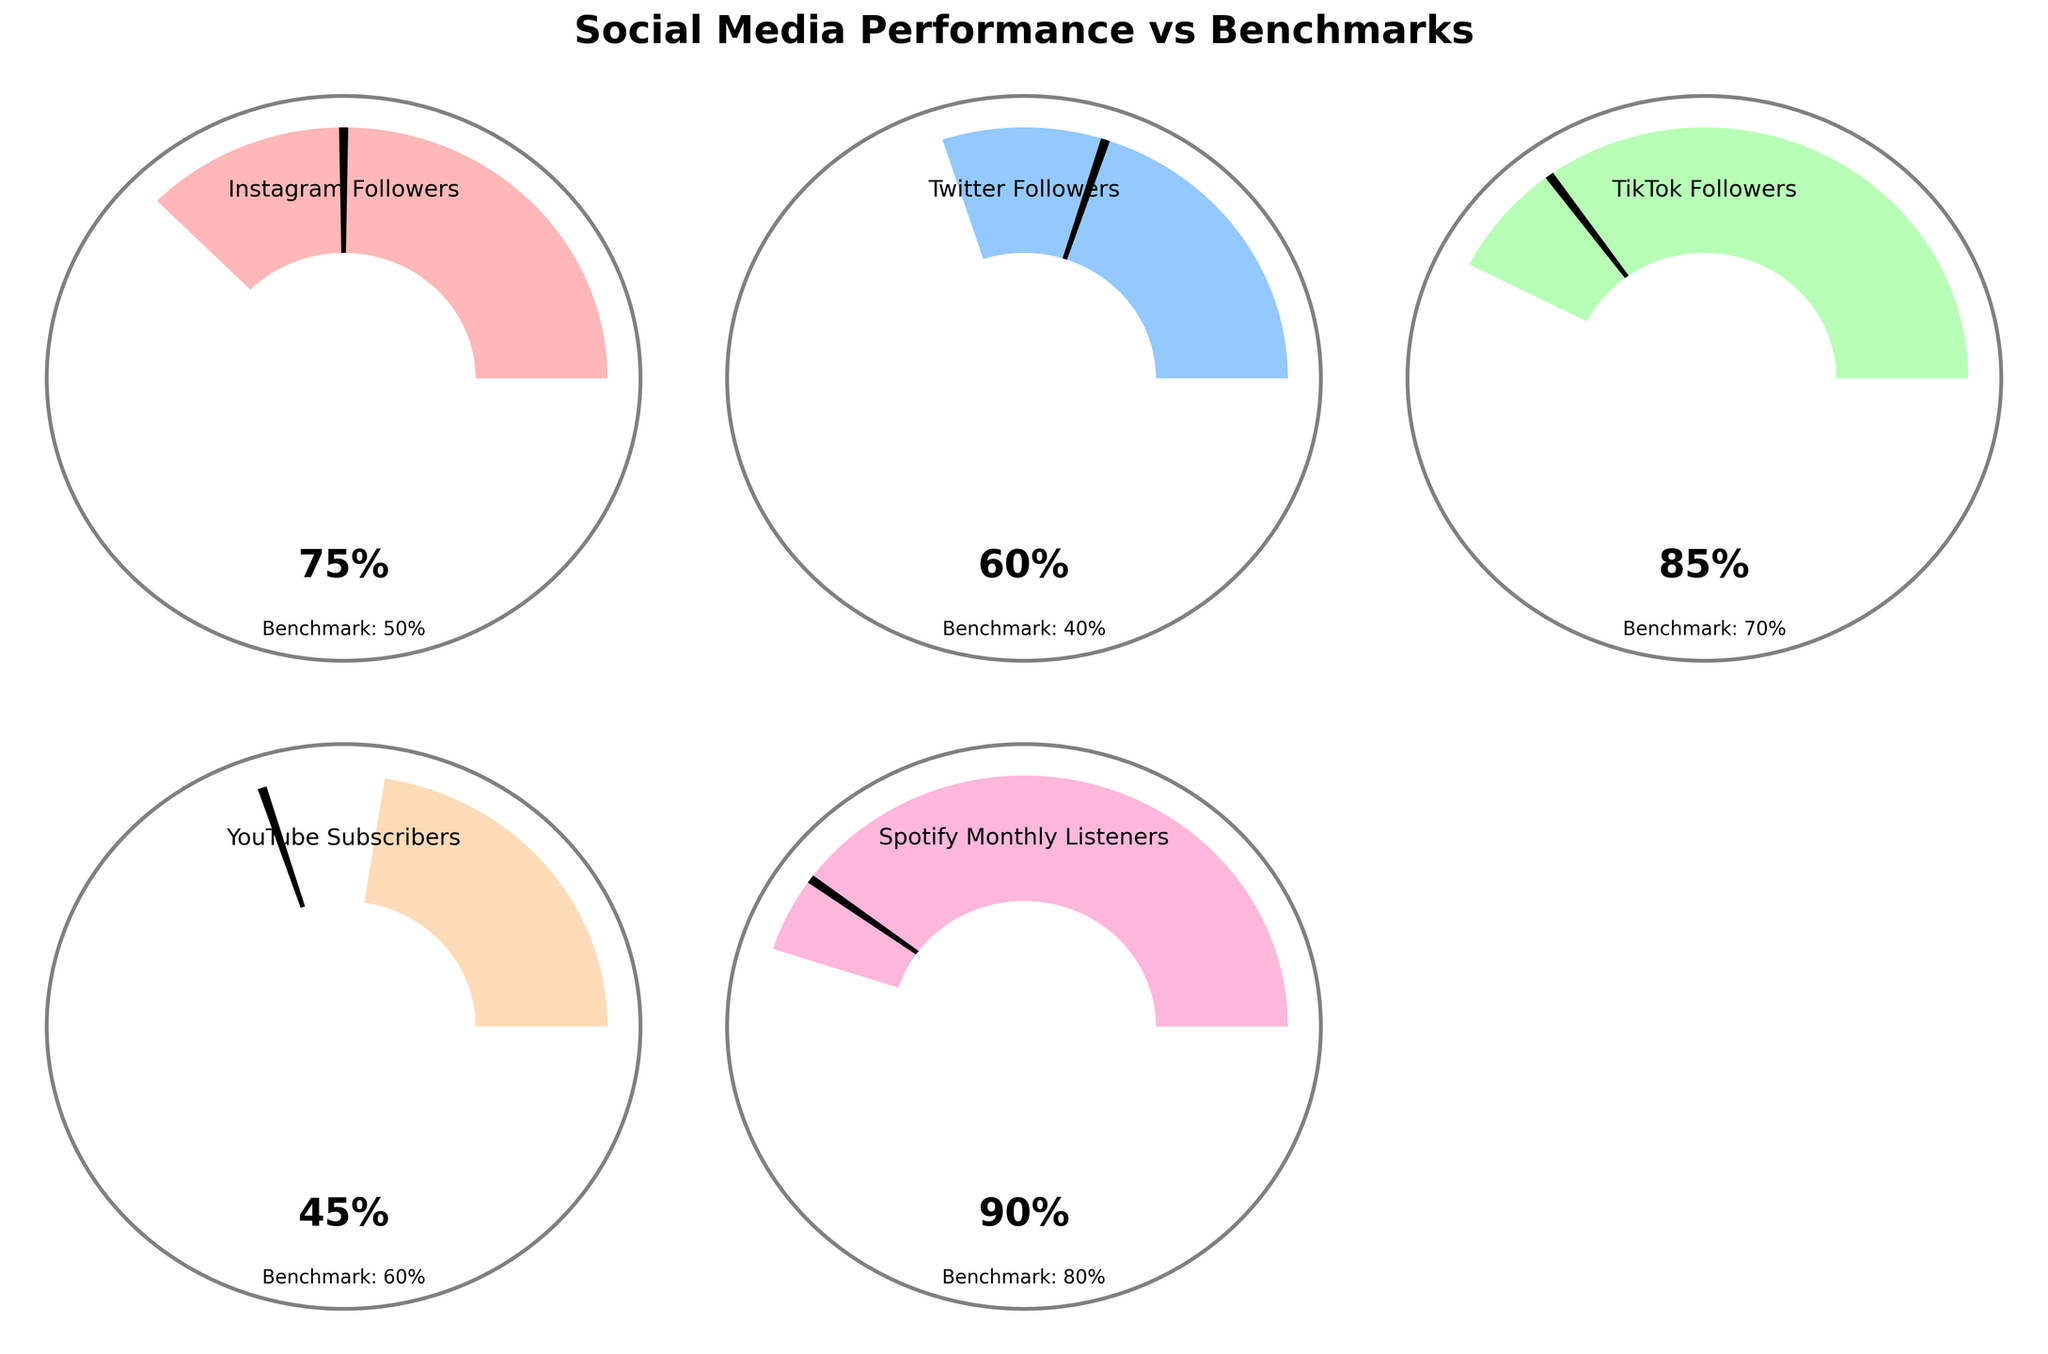What is the title of the figure? The title of the figure is displayed at the top of the plot. The text reads "Social Media Performance vs Benchmarks".
Answer: Social Media Performance vs Benchmarks Which social media category has the highest actual percentage? The data for each social media category is shown with gauge visuals. TikTok Followers has the highest actual percentage of 85%.
Answer: TikTok Followers What color represents Instagram Followers? In the figure, each category is represented by a different wedge color. Instagram Followers is represented by a light red color.
Answer: Light red How many social media categories are displayed in total on the figure? There are subplots for each data category, and counting the items listed including any empty space gives five items: Instagram Followers, Twitter Followers, TikTok Followers, YouTube Subscribers, Spotify Monthly Listeners.
Answer: Five Which social media category is the only one that shows an actual performance below its benchmark? By comparing the actual performance and the benchmark markers visually, we can see that YouTube Subscribers (45%) has an actual value lower than its benchmark of 60%.
Answer: YouTube Subscribers Which social media category is closest to its benchmark percentage? By comparing the actual and benchmark values visually, Spotify Monthly Listeners' actual value (90%) is closest to its benchmark (80%), with a difference of 10%.
Answer: Spotify Monthly Listeners On average, how does the actual follower percentage compare to the benchmark percentages across the social media platforms shown? To determine this, we calculate the average actual percentage: (75+60+85+45+90)/5 = 71%. For the benchmarks: (50+40+70+60+80)/5 = 60%. Thus, the average actual percentage is 11% higher than the benchmark percentages.
Answer: 11% higher Which category has the largest difference between actual performance and benchmark? By subtracting the benchmark percentages from the actual percentages for each category: Instagram (75-50=25), Twitter (60-40=20), TikTok (85-70=15), YouTube (45-60=-15), Spotify (90-80=10). The largest difference is 25%, for Instagram Followers.
Answer: Instagram Followers Which colors represent the Spotify Monthly Listeners and Twitter Followers categories respectively? Spotify Monthly Listeners is represented with a pink color, and Twitter Followers is represented with a blue color on the gauge plots.
Answer: Pink for Spotify, Blue for Twitter 